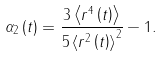Convert formula to latex. <formula><loc_0><loc_0><loc_500><loc_500>\alpha _ { 2 } \left ( t \right ) = \frac { 3 \left \langle r ^ { 4 } \left ( t \right ) \right \rangle } { 5 \left \langle r ^ { 2 } \left ( t \right ) \right \rangle ^ { 2 } } - 1 .</formula> 